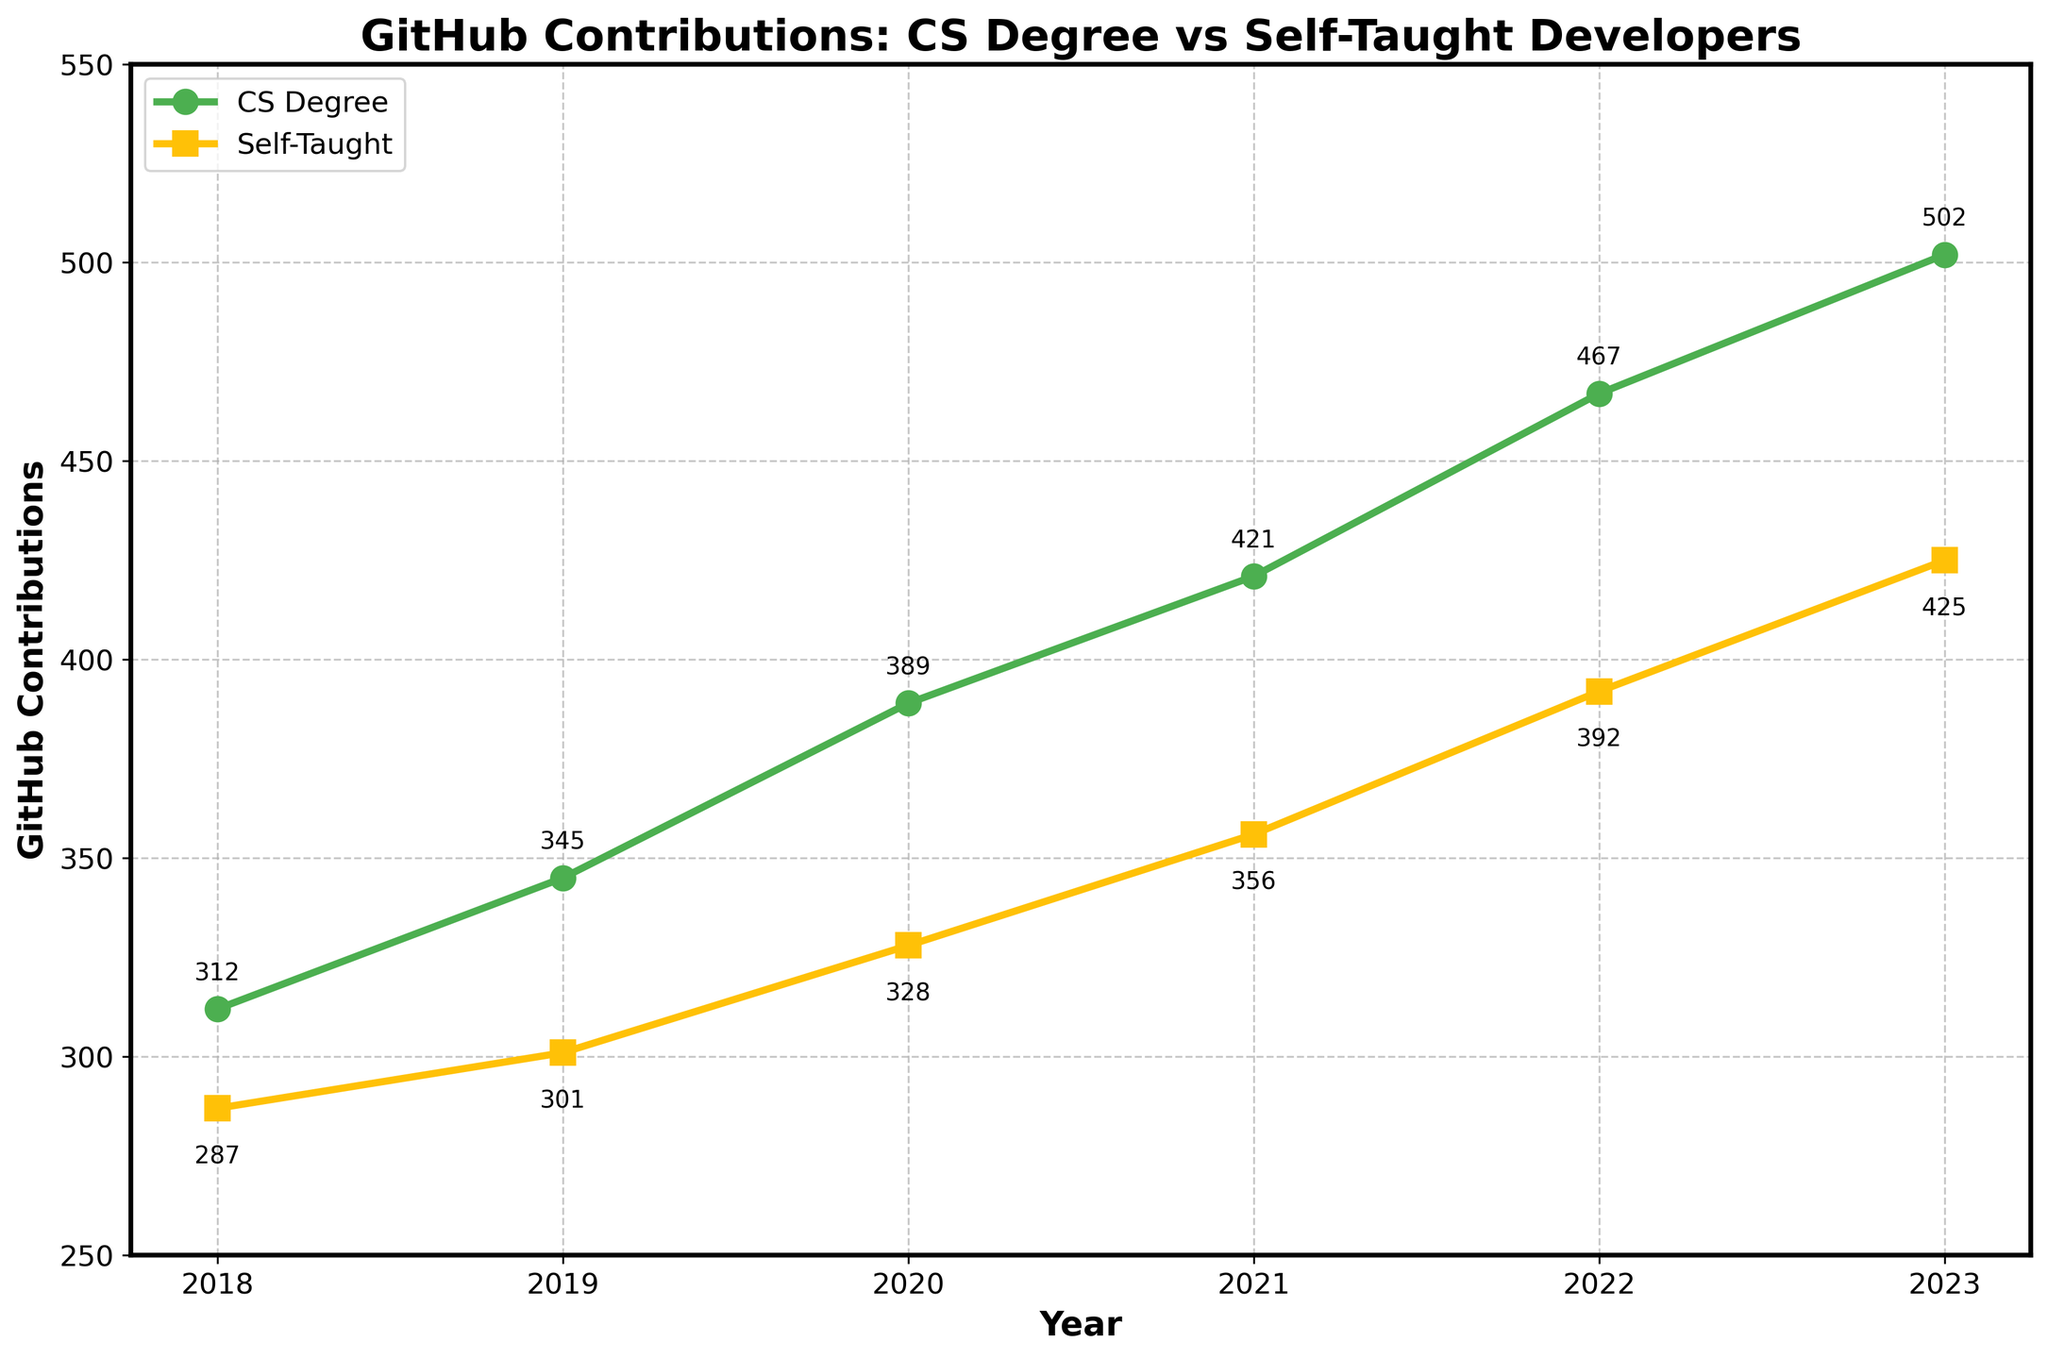Which group had the most GitHub contributions in 2018? Look at the data for 2018. CS Degree developers had 312 contributions and Self-Taught developers had 287 contributions. Compare the two values to determine which is higher.
Answer: CS Degree What is the difference in contributions between developers with a CS Degree and Self-Taught developers in 2023? The contributions for CS Degree developers in 2023 are 502, and for Self-Taught developers, it's 425. Subtract 425 from 502 to find the difference.
Answer: 77 Which year shows the smallest gap between the contributions of CS Degree and Self-Taught developers? Calculate the difference for each year between the two groups. The differences are: 2018 (25), 2019 (44), 2020 (61), 2021 (65), 2022 (75), 2023 (77). The smallest gap is 25 in 2018.
Answer: 2018 In which year did Self-Taught developers have the greatest increase in contributions compared to the previous year? Determine the increase year-over-year for Self-Taught developers: 2019-2018 (301-287 = 14), 2020-2019 (328-301 = 27), 2021-2020 (356-328 = 28), 2022-2021 (392-356 = 36), 2023-2022 (425-392=33). The largest increase is 36 contributions in 2022.
Answer: 2022 How does the trend of contributions from CS Degree developers compare to Self-Taught developers over the period? Observe the line patterns. Both groups show an upward trend, but CS Degree developers consistently contribute more each year compared to Self-Taught developers.
Answer: CS Degree consistently contributes more Approximately what was the average annual contribution for CS Degree developers from 2018 to 2023? Calculate the average by summing the contributions of CS Degree developers over the years (312 + 345 + 389 + 421 + 467 + 502 = 2436) and then dividing by the number of years (6).
Answer: 406 How many more contributions in total did CS Degree developers have compared to Self-Taught developers from 2018 to 2023? Sum the contributions for each group separately: CS Degree (2436), Self-Taught (2089). Subtract the total contributions of Self-Taught developers from CS Degree developers (2436 - 2089).
Answer: 347 In which year did both groups see the same relative increase in contributions from the previous year? Calculate the percentage increase each year for both groups. Identify any year where the increase percentages are equal (or approximately equal). Example: for 2019, CS Degree increase from 312 to 345 (~10.58%) and Self-Taught from 287 to 301 (~4.88%), and so on.
Answer: No exact match in the provided data 